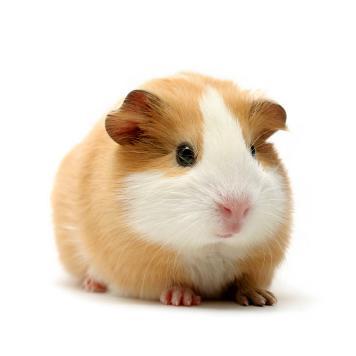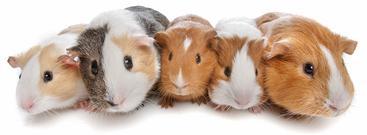The first image is the image on the left, the second image is the image on the right. Analyze the images presented: Is the assertion "Each image contains one pair of side-by-side guinea pigs and includes at least one guinea pig that is not solid colored." valid? Answer yes or no. No. The first image is the image on the left, the second image is the image on the right. Considering the images on both sides, is "Both images have two guinea pigs in them." valid? Answer yes or no. No. 